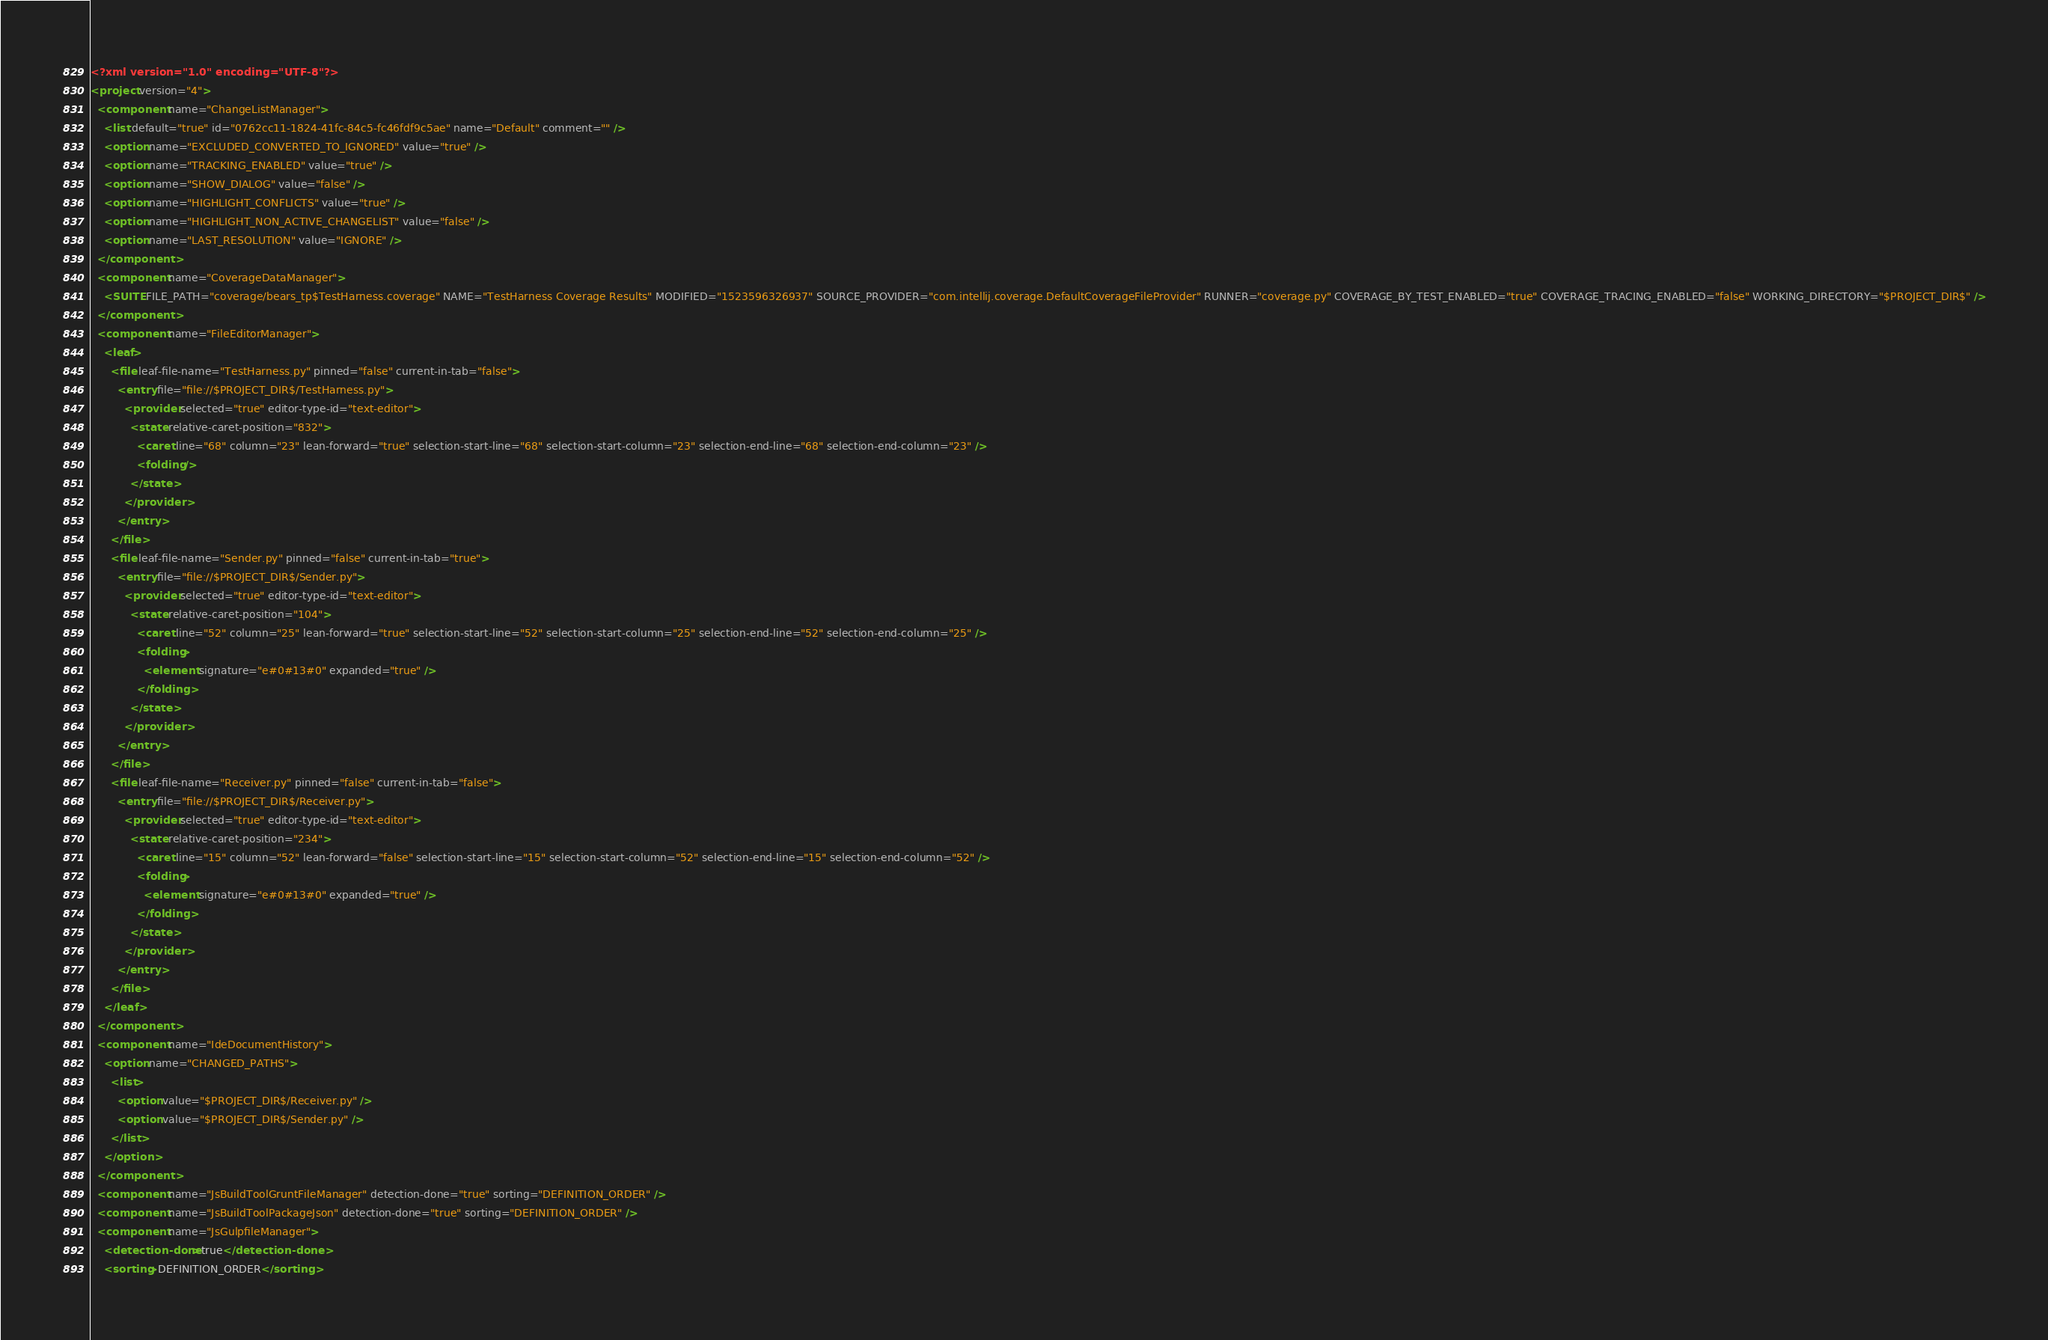<code> <loc_0><loc_0><loc_500><loc_500><_XML_><?xml version="1.0" encoding="UTF-8"?>
<project version="4">
  <component name="ChangeListManager">
    <list default="true" id="0762cc11-1824-41fc-84c5-fc46fdf9c5ae" name="Default" comment="" />
    <option name="EXCLUDED_CONVERTED_TO_IGNORED" value="true" />
    <option name="TRACKING_ENABLED" value="true" />
    <option name="SHOW_DIALOG" value="false" />
    <option name="HIGHLIGHT_CONFLICTS" value="true" />
    <option name="HIGHLIGHT_NON_ACTIVE_CHANGELIST" value="false" />
    <option name="LAST_RESOLUTION" value="IGNORE" />
  </component>
  <component name="CoverageDataManager">
    <SUITE FILE_PATH="coverage/bears_tp$TestHarness.coverage" NAME="TestHarness Coverage Results" MODIFIED="1523596326937" SOURCE_PROVIDER="com.intellij.coverage.DefaultCoverageFileProvider" RUNNER="coverage.py" COVERAGE_BY_TEST_ENABLED="true" COVERAGE_TRACING_ENABLED="false" WORKING_DIRECTORY="$PROJECT_DIR$" />
  </component>
  <component name="FileEditorManager">
    <leaf>
      <file leaf-file-name="TestHarness.py" pinned="false" current-in-tab="false">
        <entry file="file://$PROJECT_DIR$/TestHarness.py">
          <provider selected="true" editor-type-id="text-editor">
            <state relative-caret-position="832">
              <caret line="68" column="23" lean-forward="true" selection-start-line="68" selection-start-column="23" selection-end-line="68" selection-end-column="23" />
              <folding />
            </state>
          </provider>
        </entry>
      </file>
      <file leaf-file-name="Sender.py" pinned="false" current-in-tab="true">
        <entry file="file://$PROJECT_DIR$/Sender.py">
          <provider selected="true" editor-type-id="text-editor">
            <state relative-caret-position="104">
              <caret line="52" column="25" lean-forward="true" selection-start-line="52" selection-start-column="25" selection-end-line="52" selection-end-column="25" />
              <folding>
                <element signature="e#0#13#0" expanded="true" />
              </folding>
            </state>
          </provider>
        </entry>
      </file>
      <file leaf-file-name="Receiver.py" pinned="false" current-in-tab="false">
        <entry file="file://$PROJECT_DIR$/Receiver.py">
          <provider selected="true" editor-type-id="text-editor">
            <state relative-caret-position="234">
              <caret line="15" column="52" lean-forward="false" selection-start-line="15" selection-start-column="52" selection-end-line="15" selection-end-column="52" />
              <folding>
                <element signature="e#0#13#0" expanded="true" />
              </folding>
            </state>
          </provider>
        </entry>
      </file>
    </leaf>
  </component>
  <component name="IdeDocumentHistory">
    <option name="CHANGED_PATHS">
      <list>
        <option value="$PROJECT_DIR$/Receiver.py" />
        <option value="$PROJECT_DIR$/Sender.py" />
      </list>
    </option>
  </component>
  <component name="JsBuildToolGruntFileManager" detection-done="true" sorting="DEFINITION_ORDER" />
  <component name="JsBuildToolPackageJson" detection-done="true" sorting="DEFINITION_ORDER" />
  <component name="JsGulpfileManager">
    <detection-done>true</detection-done>
    <sorting>DEFINITION_ORDER</sorting></code> 